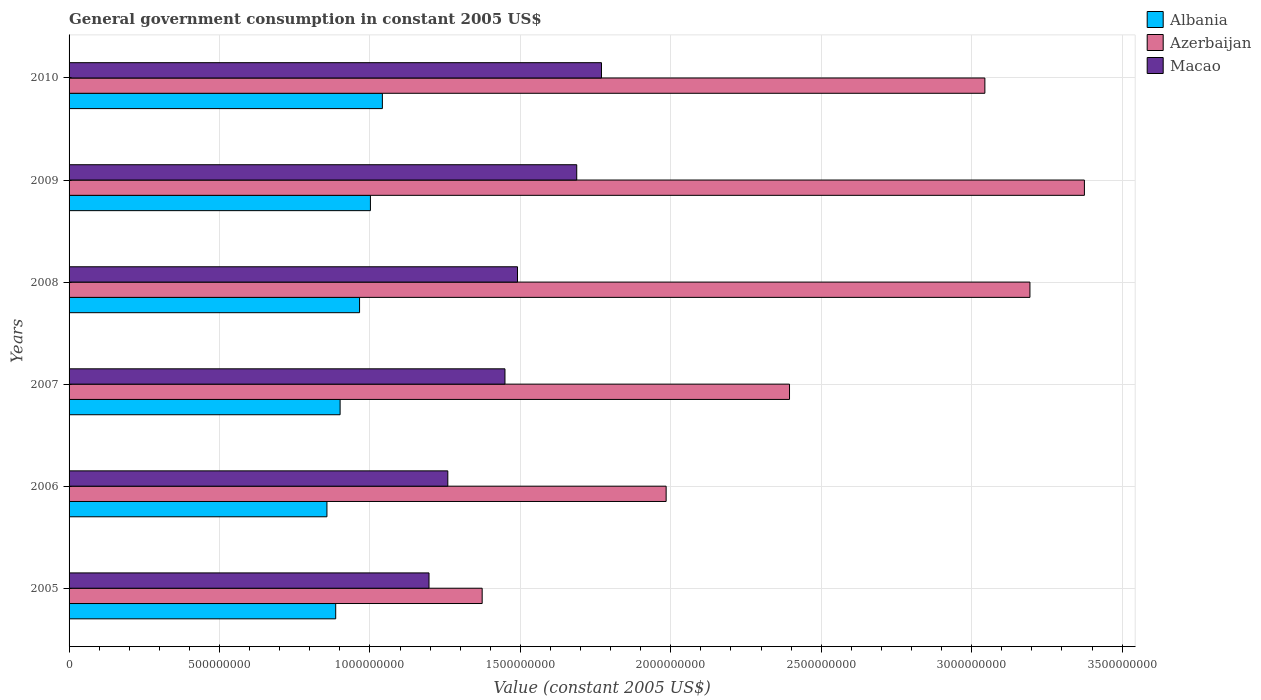How many different coloured bars are there?
Provide a short and direct response. 3. Are the number of bars per tick equal to the number of legend labels?
Your answer should be very brief. Yes. Are the number of bars on each tick of the Y-axis equal?
Your answer should be very brief. Yes. How many bars are there on the 6th tick from the top?
Give a very brief answer. 3. In how many cases, is the number of bars for a given year not equal to the number of legend labels?
Provide a succinct answer. 0. What is the government conusmption in Azerbaijan in 2007?
Your response must be concise. 2.39e+09. Across all years, what is the maximum government conusmption in Macao?
Provide a short and direct response. 1.77e+09. Across all years, what is the minimum government conusmption in Macao?
Provide a succinct answer. 1.20e+09. What is the total government conusmption in Azerbaijan in the graph?
Offer a terse response. 1.54e+1. What is the difference between the government conusmption in Macao in 2006 and that in 2007?
Your answer should be compact. -1.90e+08. What is the difference between the government conusmption in Azerbaijan in 2009 and the government conusmption in Albania in 2007?
Your answer should be very brief. 2.47e+09. What is the average government conusmption in Azerbaijan per year?
Your answer should be compact. 2.56e+09. In the year 2007, what is the difference between the government conusmption in Azerbaijan and government conusmption in Albania?
Your answer should be very brief. 1.49e+09. In how many years, is the government conusmption in Azerbaijan greater than 800000000 US$?
Offer a very short reply. 6. What is the ratio of the government conusmption in Azerbaijan in 2008 to that in 2009?
Ensure brevity in your answer.  0.95. Is the government conusmption in Azerbaijan in 2006 less than that in 2007?
Offer a terse response. Yes. What is the difference between the highest and the second highest government conusmption in Azerbaijan?
Offer a terse response. 1.81e+08. What is the difference between the highest and the lowest government conusmption in Azerbaijan?
Provide a short and direct response. 2.00e+09. What does the 3rd bar from the top in 2006 represents?
Provide a succinct answer. Albania. What does the 2nd bar from the bottom in 2010 represents?
Your response must be concise. Azerbaijan. Is it the case that in every year, the sum of the government conusmption in Azerbaijan and government conusmption in Albania is greater than the government conusmption in Macao?
Your answer should be very brief. Yes. How many bars are there?
Make the answer very short. 18. Are all the bars in the graph horizontal?
Make the answer very short. Yes. Does the graph contain grids?
Ensure brevity in your answer.  Yes. Where does the legend appear in the graph?
Give a very brief answer. Top right. How many legend labels are there?
Give a very brief answer. 3. How are the legend labels stacked?
Your answer should be compact. Vertical. What is the title of the graph?
Your response must be concise. General government consumption in constant 2005 US$. Does "Liechtenstein" appear as one of the legend labels in the graph?
Your response must be concise. No. What is the label or title of the X-axis?
Make the answer very short. Value (constant 2005 US$). What is the Value (constant 2005 US$) in Albania in 2005?
Provide a succinct answer. 8.86e+08. What is the Value (constant 2005 US$) in Azerbaijan in 2005?
Provide a short and direct response. 1.37e+09. What is the Value (constant 2005 US$) of Macao in 2005?
Your answer should be compact. 1.20e+09. What is the Value (constant 2005 US$) of Albania in 2006?
Your answer should be very brief. 8.57e+08. What is the Value (constant 2005 US$) of Azerbaijan in 2006?
Your answer should be compact. 1.98e+09. What is the Value (constant 2005 US$) in Macao in 2006?
Give a very brief answer. 1.26e+09. What is the Value (constant 2005 US$) in Albania in 2007?
Your answer should be compact. 9.01e+08. What is the Value (constant 2005 US$) in Azerbaijan in 2007?
Make the answer very short. 2.39e+09. What is the Value (constant 2005 US$) of Macao in 2007?
Give a very brief answer. 1.45e+09. What is the Value (constant 2005 US$) of Albania in 2008?
Provide a succinct answer. 9.66e+08. What is the Value (constant 2005 US$) in Azerbaijan in 2008?
Ensure brevity in your answer.  3.19e+09. What is the Value (constant 2005 US$) in Macao in 2008?
Provide a succinct answer. 1.49e+09. What is the Value (constant 2005 US$) in Albania in 2009?
Offer a terse response. 1.00e+09. What is the Value (constant 2005 US$) in Azerbaijan in 2009?
Keep it short and to the point. 3.37e+09. What is the Value (constant 2005 US$) of Macao in 2009?
Your response must be concise. 1.69e+09. What is the Value (constant 2005 US$) of Albania in 2010?
Provide a short and direct response. 1.04e+09. What is the Value (constant 2005 US$) in Azerbaijan in 2010?
Keep it short and to the point. 3.04e+09. What is the Value (constant 2005 US$) in Macao in 2010?
Offer a very short reply. 1.77e+09. Across all years, what is the maximum Value (constant 2005 US$) in Albania?
Your answer should be compact. 1.04e+09. Across all years, what is the maximum Value (constant 2005 US$) of Azerbaijan?
Make the answer very short. 3.37e+09. Across all years, what is the maximum Value (constant 2005 US$) of Macao?
Keep it short and to the point. 1.77e+09. Across all years, what is the minimum Value (constant 2005 US$) in Albania?
Ensure brevity in your answer.  8.57e+08. Across all years, what is the minimum Value (constant 2005 US$) in Azerbaijan?
Give a very brief answer. 1.37e+09. Across all years, what is the minimum Value (constant 2005 US$) in Macao?
Provide a short and direct response. 1.20e+09. What is the total Value (constant 2005 US$) in Albania in the graph?
Give a very brief answer. 5.65e+09. What is the total Value (constant 2005 US$) in Azerbaijan in the graph?
Provide a short and direct response. 1.54e+1. What is the total Value (constant 2005 US$) of Macao in the graph?
Provide a short and direct response. 8.85e+09. What is the difference between the Value (constant 2005 US$) of Albania in 2005 and that in 2006?
Your answer should be compact. 2.92e+07. What is the difference between the Value (constant 2005 US$) of Azerbaijan in 2005 and that in 2006?
Offer a terse response. -6.11e+08. What is the difference between the Value (constant 2005 US$) in Macao in 2005 and that in 2006?
Make the answer very short. -6.25e+07. What is the difference between the Value (constant 2005 US$) of Albania in 2005 and that in 2007?
Your answer should be very brief. -1.46e+07. What is the difference between the Value (constant 2005 US$) of Azerbaijan in 2005 and that in 2007?
Provide a short and direct response. -1.02e+09. What is the difference between the Value (constant 2005 US$) of Macao in 2005 and that in 2007?
Offer a very short reply. -2.52e+08. What is the difference between the Value (constant 2005 US$) in Albania in 2005 and that in 2008?
Give a very brief answer. -7.93e+07. What is the difference between the Value (constant 2005 US$) of Azerbaijan in 2005 and that in 2008?
Provide a short and direct response. -1.82e+09. What is the difference between the Value (constant 2005 US$) of Macao in 2005 and that in 2008?
Your answer should be compact. -2.94e+08. What is the difference between the Value (constant 2005 US$) in Albania in 2005 and that in 2009?
Your answer should be compact. -1.15e+08. What is the difference between the Value (constant 2005 US$) in Azerbaijan in 2005 and that in 2009?
Give a very brief answer. -2.00e+09. What is the difference between the Value (constant 2005 US$) in Macao in 2005 and that in 2009?
Provide a short and direct response. -4.91e+08. What is the difference between the Value (constant 2005 US$) in Albania in 2005 and that in 2010?
Give a very brief answer. -1.55e+08. What is the difference between the Value (constant 2005 US$) in Azerbaijan in 2005 and that in 2010?
Offer a very short reply. -1.67e+09. What is the difference between the Value (constant 2005 US$) of Macao in 2005 and that in 2010?
Your response must be concise. -5.73e+08. What is the difference between the Value (constant 2005 US$) in Albania in 2006 and that in 2007?
Keep it short and to the point. -4.38e+07. What is the difference between the Value (constant 2005 US$) in Azerbaijan in 2006 and that in 2007?
Your answer should be compact. -4.10e+08. What is the difference between the Value (constant 2005 US$) in Macao in 2006 and that in 2007?
Keep it short and to the point. -1.90e+08. What is the difference between the Value (constant 2005 US$) of Albania in 2006 and that in 2008?
Your answer should be compact. -1.08e+08. What is the difference between the Value (constant 2005 US$) of Azerbaijan in 2006 and that in 2008?
Provide a succinct answer. -1.21e+09. What is the difference between the Value (constant 2005 US$) in Macao in 2006 and that in 2008?
Your answer should be very brief. -2.32e+08. What is the difference between the Value (constant 2005 US$) in Albania in 2006 and that in 2009?
Your answer should be very brief. -1.45e+08. What is the difference between the Value (constant 2005 US$) in Azerbaijan in 2006 and that in 2009?
Provide a succinct answer. -1.39e+09. What is the difference between the Value (constant 2005 US$) of Macao in 2006 and that in 2009?
Keep it short and to the point. -4.29e+08. What is the difference between the Value (constant 2005 US$) of Albania in 2006 and that in 2010?
Your answer should be compact. -1.84e+08. What is the difference between the Value (constant 2005 US$) in Azerbaijan in 2006 and that in 2010?
Provide a succinct answer. -1.06e+09. What is the difference between the Value (constant 2005 US$) of Macao in 2006 and that in 2010?
Offer a terse response. -5.11e+08. What is the difference between the Value (constant 2005 US$) in Albania in 2007 and that in 2008?
Offer a terse response. -6.47e+07. What is the difference between the Value (constant 2005 US$) of Azerbaijan in 2007 and that in 2008?
Your answer should be very brief. -7.99e+08. What is the difference between the Value (constant 2005 US$) in Macao in 2007 and that in 2008?
Offer a terse response. -4.17e+07. What is the difference between the Value (constant 2005 US$) in Albania in 2007 and that in 2009?
Make the answer very short. -1.01e+08. What is the difference between the Value (constant 2005 US$) in Azerbaijan in 2007 and that in 2009?
Provide a short and direct response. -9.80e+08. What is the difference between the Value (constant 2005 US$) in Macao in 2007 and that in 2009?
Offer a very short reply. -2.39e+08. What is the difference between the Value (constant 2005 US$) in Albania in 2007 and that in 2010?
Provide a short and direct response. -1.41e+08. What is the difference between the Value (constant 2005 US$) of Azerbaijan in 2007 and that in 2010?
Give a very brief answer. -6.49e+08. What is the difference between the Value (constant 2005 US$) in Macao in 2007 and that in 2010?
Your answer should be compact. -3.21e+08. What is the difference between the Value (constant 2005 US$) in Albania in 2008 and that in 2009?
Offer a very short reply. -3.61e+07. What is the difference between the Value (constant 2005 US$) in Azerbaijan in 2008 and that in 2009?
Provide a short and direct response. -1.81e+08. What is the difference between the Value (constant 2005 US$) of Macao in 2008 and that in 2009?
Your response must be concise. -1.97e+08. What is the difference between the Value (constant 2005 US$) in Albania in 2008 and that in 2010?
Make the answer very short. -7.58e+07. What is the difference between the Value (constant 2005 US$) in Azerbaijan in 2008 and that in 2010?
Make the answer very short. 1.50e+08. What is the difference between the Value (constant 2005 US$) in Macao in 2008 and that in 2010?
Your answer should be very brief. -2.79e+08. What is the difference between the Value (constant 2005 US$) of Albania in 2009 and that in 2010?
Your answer should be compact. -3.97e+07. What is the difference between the Value (constant 2005 US$) in Azerbaijan in 2009 and that in 2010?
Your answer should be compact. 3.31e+08. What is the difference between the Value (constant 2005 US$) in Macao in 2009 and that in 2010?
Give a very brief answer. -8.23e+07. What is the difference between the Value (constant 2005 US$) in Albania in 2005 and the Value (constant 2005 US$) in Azerbaijan in 2006?
Give a very brief answer. -1.10e+09. What is the difference between the Value (constant 2005 US$) of Albania in 2005 and the Value (constant 2005 US$) of Macao in 2006?
Make the answer very short. -3.73e+08. What is the difference between the Value (constant 2005 US$) of Azerbaijan in 2005 and the Value (constant 2005 US$) of Macao in 2006?
Offer a very short reply. 1.14e+08. What is the difference between the Value (constant 2005 US$) in Albania in 2005 and the Value (constant 2005 US$) in Azerbaijan in 2007?
Provide a short and direct response. -1.51e+09. What is the difference between the Value (constant 2005 US$) in Albania in 2005 and the Value (constant 2005 US$) in Macao in 2007?
Offer a terse response. -5.63e+08. What is the difference between the Value (constant 2005 US$) in Azerbaijan in 2005 and the Value (constant 2005 US$) in Macao in 2007?
Keep it short and to the point. -7.57e+07. What is the difference between the Value (constant 2005 US$) of Albania in 2005 and the Value (constant 2005 US$) of Azerbaijan in 2008?
Keep it short and to the point. -2.31e+09. What is the difference between the Value (constant 2005 US$) of Albania in 2005 and the Value (constant 2005 US$) of Macao in 2008?
Provide a succinct answer. -6.04e+08. What is the difference between the Value (constant 2005 US$) of Azerbaijan in 2005 and the Value (constant 2005 US$) of Macao in 2008?
Give a very brief answer. -1.17e+08. What is the difference between the Value (constant 2005 US$) in Albania in 2005 and the Value (constant 2005 US$) in Azerbaijan in 2009?
Keep it short and to the point. -2.49e+09. What is the difference between the Value (constant 2005 US$) of Albania in 2005 and the Value (constant 2005 US$) of Macao in 2009?
Make the answer very short. -8.01e+08. What is the difference between the Value (constant 2005 US$) of Azerbaijan in 2005 and the Value (constant 2005 US$) of Macao in 2009?
Your answer should be very brief. -3.14e+08. What is the difference between the Value (constant 2005 US$) of Albania in 2005 and the Value (constant 2005 US$) of Azerbaijan in 2010?
Ensure brevity in your answer.  -2.16e+09. What is the difference between the Value (constant 2005 US$) in Albania in 2005 and the Value (constant 2005 US$) in Macao in 2010?
Make the answer very short. -8.83e+08. What is the difference between the Value (constant 2005 US$) of Azerbaijan in 2005 and the Value (constant 2005 US$) of Macao in 2010?
Make the answer very short. -3.97e+08. What is the difference between the Value (constant 2005 US$) in Albania in 2006 and the Value (constant 2005 US$) in Azerbaijan in 2007?
Give a very brief answer. -1.54e+09. What is the difference between the Value (constant 2005 US$) in Albania in 2006 and the Value (constant 2005 US$) in Macao in 2007?
Offer a terse response. -5.92e+08. What is the difference between the Value (constant 2005 US$) in Azerbaijan in 2006 and the Value (constant 2005 US$) in Macao in 2007?
Offer a very short reply. 5.36e+08. What is the difference between the Value (constant 2005 US$) of Albania in 2006 and the Value (constant 2005 US$) of Azerbaijan in 2008?
Your answer should be very brief. -2.34e+09. What is the difference between the Value (constant 2005 US$) of Albania in 2006 and the Value (constant 2005 US$) of Macao in 2008?
Offer a very short reply. -6.33e+08. What is the difference between the Value (constant 2005 US$) of Azerbaijan in 2006 and the Value (constant 2005 US$) of Macao in 2008?
Provide a succinct answer. 4.94e+08. What is the difference between the Value (constant 2005 US$) in Albania in 2006 and the Value (constant 2005 US$) in Azerbaijan in 2009?
Ensure brevity in your answer.  -2.52e+09. What is the difference between the Value (constant 2005 US$) of Albania in 2006 and the Value (constant 2005 US$) of Macao in 2009?
Provide a succinct answer. -8.30e+08. What is the difference between the Value (constant 2005 US$) in Azerbaijan in 2006 and the Value (constant 2005 US$) in Macao in 2009?
Ensure brevity in your answer.  2.97e+08. What is the difference between the Value (constant 2005 US$) of Albania in 2006 and the Value (constant 2005 US$) of Azerbaijan in 2010?
Make the answer very short. -2.19e+09. What is the difference between the Value (constant 2005 US$) in Albania in 2006 and the Value (constant 2005 US$) in Macao in 2010?
Offer a very short reply. -9.13e+08. What is the difference between the Value (constant 2005 US$) in Azerbaijan in 2006 and the Value (constant 2005 US$) in Macao in 2010?
Give a very brief answer. 2.15e+08. What is the difference between the Value (constant 2005 US$) of Albania in 2007 and the Value (constant 2005 US$) of Azerbaijan in 2008?
Your answer should be very brief. -2.29e+09. What is the difference between the Value (constant 2005 US$) in Albania in 2007 and the Value (constant 2005 US$) in Macao in 2008?
Your answer should be very brief. -5.90e+08. What is the difference between the Value (constant 2005 US$) in Azerbaijan in 2007 and the Value (constant 2005 US$) in Macao in 2008?
Ensure brevity in your answer.  9.04e+08. What is the difference between the Value (constant 2005 US$) in Albania in 2007 and the Value (constant 2005 US$) in Azerbaijan in 2009?
Offer a very short reply. -2.47e+09. What is the difference between the Value (constant 2005 US$) in Albania in 2007 and the Value (constant 2005 US$) in Macao in 2009?
Ensure brevity in your answer.  -7.87e+08. What is the difference between the Value (constant 2005 US$) of Azerbaijan in 2007 and the Value (constant 2005 US$) of Macao in 2009?
Your answer should be compact. 7.07e+08. What is the difference between the Value (constant 2005 US$) of Albania in 2007 and the Value (constant 2005 US$) of Azerbaijan in 2010?
Offer a very short reply. -2.14e+09. What is the difference between the Value (constant 2005 US$) of Albania in 2007 and the Value (constant 2005 US$) of Macao in 2010?
Give a very brief answer. -8.69e+08. What is the difference between the Value (constant 2005 US$) in Azerbaijan in 2007 and the Value (constant 2005 US$) in Macao in 2010?
Offer a terse response. 6.25e+08. What is the difference between the Value (constant 2005 US$) in Albania in 2008 and the Value (constant 2005 US$) in Azerbaijan in 2009?
Your answer should be compact. -2.41e+09. What is the difference between the Value (constant 2005 US$) of Albania in 2008 and the Value (constant 2005 US$) of Macao in 2009?
Offer a very short reply. -7.22e+08. What is the difference between the Value (constant 2005 US$) in Azerbaijan in 2008 and the Value (constant 2005 US$) in Macao in 2009?
Your answer should be compact. 1.51e+09. What is the difference between the Value (constant 2005 US$) of Albania in 2008 and the Value (constant 2005 US$) of Azerbaijan in 2010?
Offer a terse response. -2.08e+09. What is the difference between the Value (constant 2005 US$) of Albania in 2008 and the Value (constant 2005 US$) of Macao in 2010?
Your response must be concise. -8.04e+08. What is the difference between the Value (constant 2005 US$) in Azerbaijan in 2008 and the Value (constant 2005 US$) in Macao in 2010?
Provide a short and direct response. 1.42e+09. What is the difference between the Value (constant 2005 US$) of Albania in 2009 and the Value (constant 2005 US$) of Azerbaijan in 2010?
Offer a very short reply. -2.04e+09. What is the difference between the Value (constant 2005 US$) of Albania in 2009 and the Value (constant 2005 US$) of Macao in 2010?
Give a very brief answer. -7.68e+08. What is the difference between the Value (constant 2005 US$) of Azerbaijan in 2009 and the Value (constant 2005 US$) of Macao in 2010?
Your answer should be very brief. 1.61e+09. What is the average Value (constant 2005 US$) in Albania per year?
Keep it short and to the point. 9.42e+08. What is the average Value (constant 2005 US$) in Azerbaijan per year?
Provide a succinct answer. 2.56e+09. What is the average Value (constant 2005 US$) in Macao per year?
Your response must be concise. 1.48e+09. In the year 2005, what is the difference between the Value (constant 2005 US$) of Albania and Value (constant 2005 US$) of Azerbaijan?
Provide a succinct answer. -4.87e+08. In the year 2005, what is the difference between the Value (constant 2005 US$) in Albania and Value (constant 2005 US$) in Macao?
Your answer should be very brief. -3.10e+08. In the year 2005, what is the difference between the Value (constant 2005 US$) of Azerbaijan and Value (constant 2005 US$) of Macao?
Keep it short and to the point. 1.77e+08. In the year 2006, what is the difference between the Value (constant 2005 US$) of Albania and Value (constant 2005 US$) of Azerbaijan?
Provide a short and direct response. -1.13e+09. In the year 2006, what is the difference between the Value (constant 2005 US$) in Albania and Value (constant 2005 US$) in Macao?
Your response must be concise. -4.02e+08. In the year 2006, what is the difference between the Value (constant 2005 US$) of Azerbaijan and Value (constant 2005 US$) of Macao?
Your answer should be compact. 7.26e+08. In the year 2007, what is the difference between the Value (constant 2005 US$) of Albania and Value (constant 2005 US$) of Azerbaijan?
Your answer should be very brief. -1.49e+09. In the year 2007, what is the difference between the Value (constant 2005 US$) in Albania and Value (constant 2005 US$) in Macao?
Give a very brief answer. -5.48e+08. In the year 2007, what is the difference between the Value (constant 2005 US$) in Azerbaijan and Value (constant 2005 US$) in Macao?
Provide a short and direct response. 9.46e+08. In the year 2008, what is the difference between the Value (constant 2005 US$) of Albania and Value (constant 2005 US$) of Azerbaijan?
Provide a short and direct response. -2.23e+09. In the year 2008, what is the difference between the Value (constant 2005 US$) of Albania and Value (constant 2005 US$) of Macao?
Keep it short and to the point. -5.25e+08. In the year 2008, what is the difference between the Value (constant 2005 US$) of Azerbaijan and Value (constant 2005 US$) of Macao?
Your answer should be compact. 1.70e+09. In the year 2009, what is the difference between the Value (constant 2005 US$) of Albania and Value (constant 2005 US$) of Azerbaijan?
Keep it short and to the point. -2.37e+09. In the year 2009, what is the difference between the Value (constant 2005 US$) in Albania and Value (constant 2005 US$) in Macao?
Make the answer very short. -6.86e+08. In the year 2009, what is the difference between the Value (constant 2005 US$) of Azerbaijan and Value (constant 2005 US$) of Macao?
Give a very brief answer. 1.69e+09. In the year 2010, what is the difference between the Value (constant 2005 US$) of Albania and Value (constant 2005 US$) of Azerbaijan?
Your answer should be compact. -2.00e+09. In the year 2010, what is the difference between the Value (constant 2005 US$) in Albania and Value (constant 2005 US$) in Macao?
Ensure brevity in your answer.  -7.28e+08. In the year 2010, what is the difference between the Value (constant 2005 US$) of Azerbaijan and Value (constant 2005 US$) of Macao?
Ensure brevity in your answer.  1.27e+09. What is the ratio of the Value (constant 2005 US$) in Albania in 2005 to that in 2006?
Your answer should be very brief. 1.03. What is the ratio of the Value (constant 2005 US$) in Azerbaijan in 2005 to that in 2006?
Make the answer very short. 0.69. What is the ratio of the Value (constant 2005 US$) in Macao in 2005 to that in 2006?
Your response must be concise. 0.95. What is the ratio of the Value (constant 2005 US$) in Albania in 2005 to that in 2007?
Make the answer very short. 0.98. What is the ratio of the Value (constant 2005 US$) of Azerbaijan in 2005 to that in 2007?
Provide a succinct answer. 0.57. What is the ratio of the Value (constant 2005 US$) in Macao in 2005 to that in 2007?
Your answer should be very brief. 0.83. What is the ratio of the Value (constant 2005 US$) in Albania in 2005 to that in 2008?
Provide a succinct answer. 0.92. What is the ratio of the Value (constant 2005 US$) in Azerbaijan in 2005 to that in 2008?
Your answer should be compact. 0.43. What is the ratio of the Value (constant 2005 US$) of Macao in 2005 to that in 2008?
Your response must be concise. 0.8. What is the ratio of the Value (constant 2005 US$) of Albania in 2005 to that in 2009?
Offer a very short reply. 0.88. What is the ratio of the Value (constant 2005 US$) of Azerbaijan in 2005 to that in 2009?
Offer a very short reply. 0.41. What is the ratio of the Value (constant 2005 US$) of Macao in 2005 to that in 2009?
Your answer should be compact. 0.71. What is the ratio of the Value (constant 2005 US$) of Albania in 2005 to that in 2010?
Ensure brevity in your answer.  0.85. What is the ratio of the Value (constant 2005 US$) in Azerbaijan in 2005 to that in 2010?
Your answer should be very brief. 0.45. What is the ratio of the Value (constant 2005 US$) of Macao in 2005 to that in 2010?
Your response must be concise. 0.68. What is the ratio of the Value (constant 2005 US$) in Albania in 2006 to that in 2007?
Provide a short and direct response. 0.95. What is the ratio of the Value (constant 2005 US$) of Azerbaijan in 2006 to that in 2007?
Provide a short and direct response. 0.83. What is the ratio of the Value (constant 2005 US$) of Macao in 2006 to that in 2007?
Provide a short and direct response. 0.87. What is the ratio of the Value (constant 2005 US$) of Albania in 2006 to that in 2008?
Make the answer very short. 0.89. What is the ratio of the Value (constant 2005 US$) of Azerbaijan in 2006 to that in 2008?
Make the answer very short. 0.62. What is the ratio of the Value (constant 2005 US$) of Macao in 2006 to that in 2008?
Your answer should be very brief. 0.84. What is the ratio of the Value (constant 2005 US$) in Albania in 2006 to that in 2009?
Provide a short and direct response. 0.86. What is the ratio of the Value (constant 2005 US$) in Azerbaijan in 2006 to that in 2009?
Offer a terse response. 0.59. What is the ratio of the Value (constant 2005 US$) of Macao in 2006 to that in 2009?
Make the answer very short. 0.75. What is the ratio of the Value (constant 2005 US$) of Albania in 2006 to that in 2010?
Provide a short and direct response. 0.82. What is the ratio of the Value (constant 2005 US$) in Azerbaijan in 2006 to that in 2010?
Keep it short and to the point. 0.65. What is the ratio of the Value (constant 2005 US$) in Macao in 2006 to that in 2010?
Ensure brevity in your answer.  0.71. What is the ratio of the Value (constant 2005 US$) in Albania in 2007 to that in 2008?
Offer a terse response. 0.93. What is the ratio of the Value (constant 2005 US$) in Azerbaijan in 2007 to that in 2008?
Your answer should be very brief. 0.75. What is the ratio of the Value (constant 2005 US$) of Macao in 2007 to that in 2008?
Your answer should be very brief. 0.97. What is the ratio of the Value (constant 2005 US$) of Albania in 2007 to that in 2009?
Provide a succinct answer. 0.9. What is the ratio of the Value (constant 2005 US$) in Azerbaijan in 2007 to that in 2009?
Make the answer very short. 0.71. What is the ratio of the Value (constant 2005 US$) of Macao in 2007 to that in 2009?
Give a very brief answer. 0.86. What is the ratio of the Value (constant 2005 US$) in Albania in 2007 to that in 2010?
Offer a very short reply. 0.87. What is the ratio of the Value (constant 2005 US$) of Azerbaijan in 2007 to that in 2010?
Your answer should be very brief. 0.79. What is the ratio of the Value (constant 2005 US$) in Macao in 2007 to that in 2010?
Ensure brevity in your answer.  0.82. What is the ratio of the Value (constant 2005 US$) in Azerbaijan in 2008 to that in 2009?
Your answer should be compact. 0.95. What is the ratio of the Value (constant 2005 US$) in Macao in 2008 to that in 2009?
Give a very brief answer. 0.88. What is the ratio of the Value (constant 2005 US$) of Albania in 2008 to that in 2010?
Give a very brief answer. 0.93. What is the ratio of the Value (constant 2005 US$) of Azerbaijan in 2008 to that in 2010?
Make the answer very short. 1.05. What is the ratio of the Value (constant 2005 US$) of Macao in 2008 to that in 2010?
Offer a terse response. 0.84. What is the ratio of the Value (constant 2005 US$) of Albania in 2009 to that in 2010?
Give a very brief answer. 0.96. What is the ratio of the Value (constant 2005 US$) in Azerbaijan in 2009 to that in 2010?
Ensure brevity in your answer.  1.11. What is the ratio of the Value (constant 2005 US$) in Macao in 2009 to that in 2010?
Keep it short and to the point. 0.95. What is the difference between the highest and the second highest Value (constant 2005 US$) in Albania?
Offer a very short reply. 3.97e+07. What is the difference between the highest and the second highest Value (constant 2005 US$) in Azerbaijan?
Give a very brief answer. 1.81e+08. What is the difference between the highest and the second highest Value (constant 2005 US$) of Macao?
Provide a short and direct response. 8.23e+07. What is the difference between the highest and the lowest Value (constant 2005 US$) of Albania?
Provide a short and direct response. 1.84e+08. What is the difference between the highest and the lowest Value (constant 2005 US$) in Azerbaijan?
Provide a short and direct response. 2.00e+09. What is the difference between the highest and the lowest Value (constant 2005 US$) of Macao?
Offer a very short reply. 5.73e+08. 